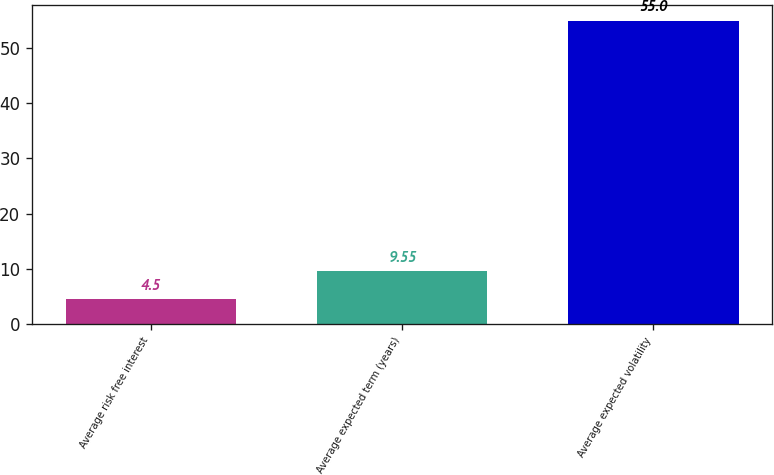Convert chart. <chart><loc_0><loc_0><loc_500><loc_500><bar_chart><fcel>Average risk free interest<fcel>Average expected term (years)<fcel>Average expected volatility<nl><fcel>4.5<fcel>9.55<fcel>55<nl></chart> 